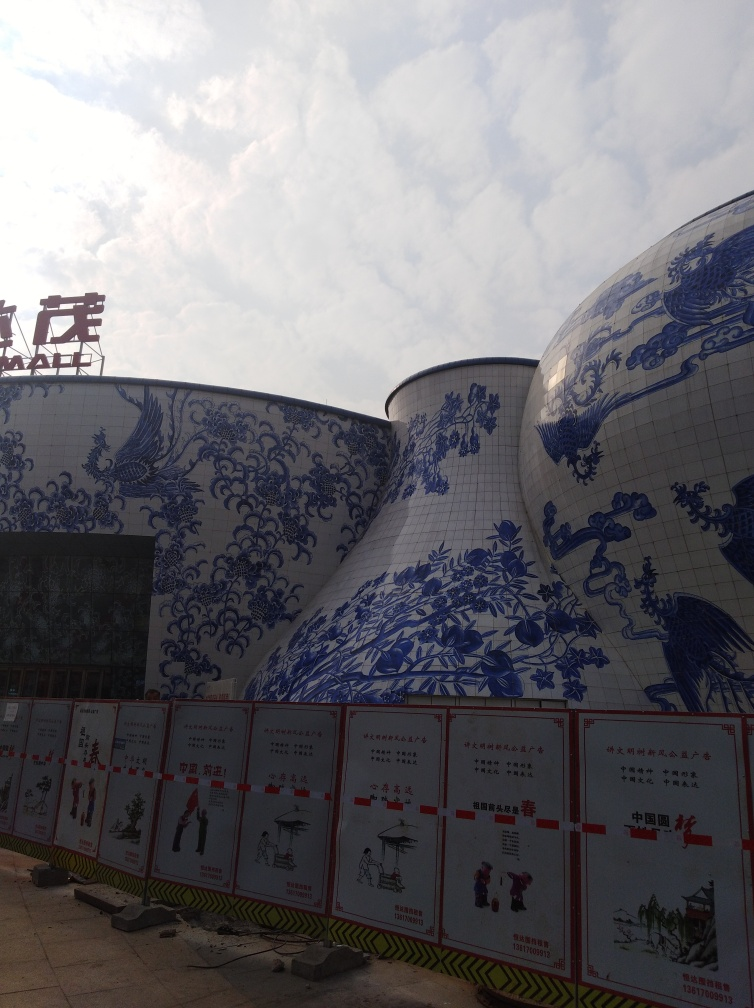Is there any motion blur in the image?
 No 